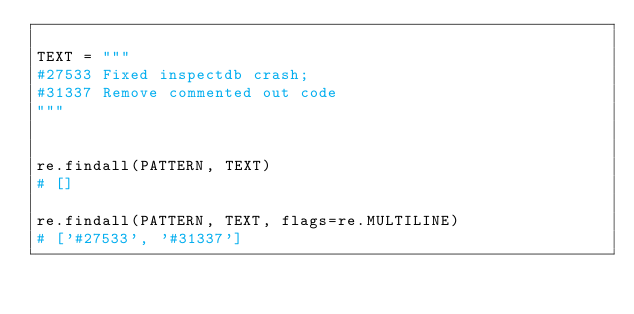<code> <loc_0><loc_0><loc_500><loc_500><_Python_>
TEXT = """
#27533 Fixed inspectdb crash;
#31337 Remove commented out code
"""


re.findall(PATTERN, TEXT)
# []

re.findall(PATTERN, TEXT, flags=re.MULTILINE)
# ['#27533', '#31337']
</code> 